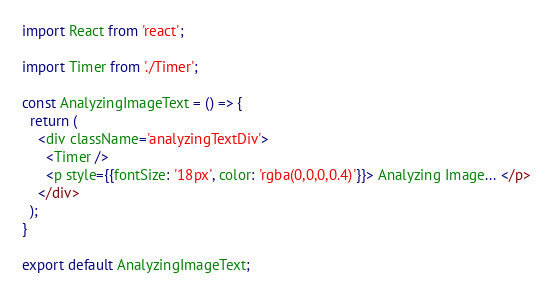Convert code to text. <code><loc_0><loc_0><loc_500><loc_500><_JavaScript_>import React from 'react';

import Timer from './Timer';

const AnalyzingImageText = () => {
  return (
    <div className='analyzingTextDiv'>
      <Timer />
      <p style={{fontSize: '18px', color: 'rgba(0,0,0,0.4)'}}> Analyzing Image... </p>
    </div>
  );
}

export default AnalyzingImageText;</code> 